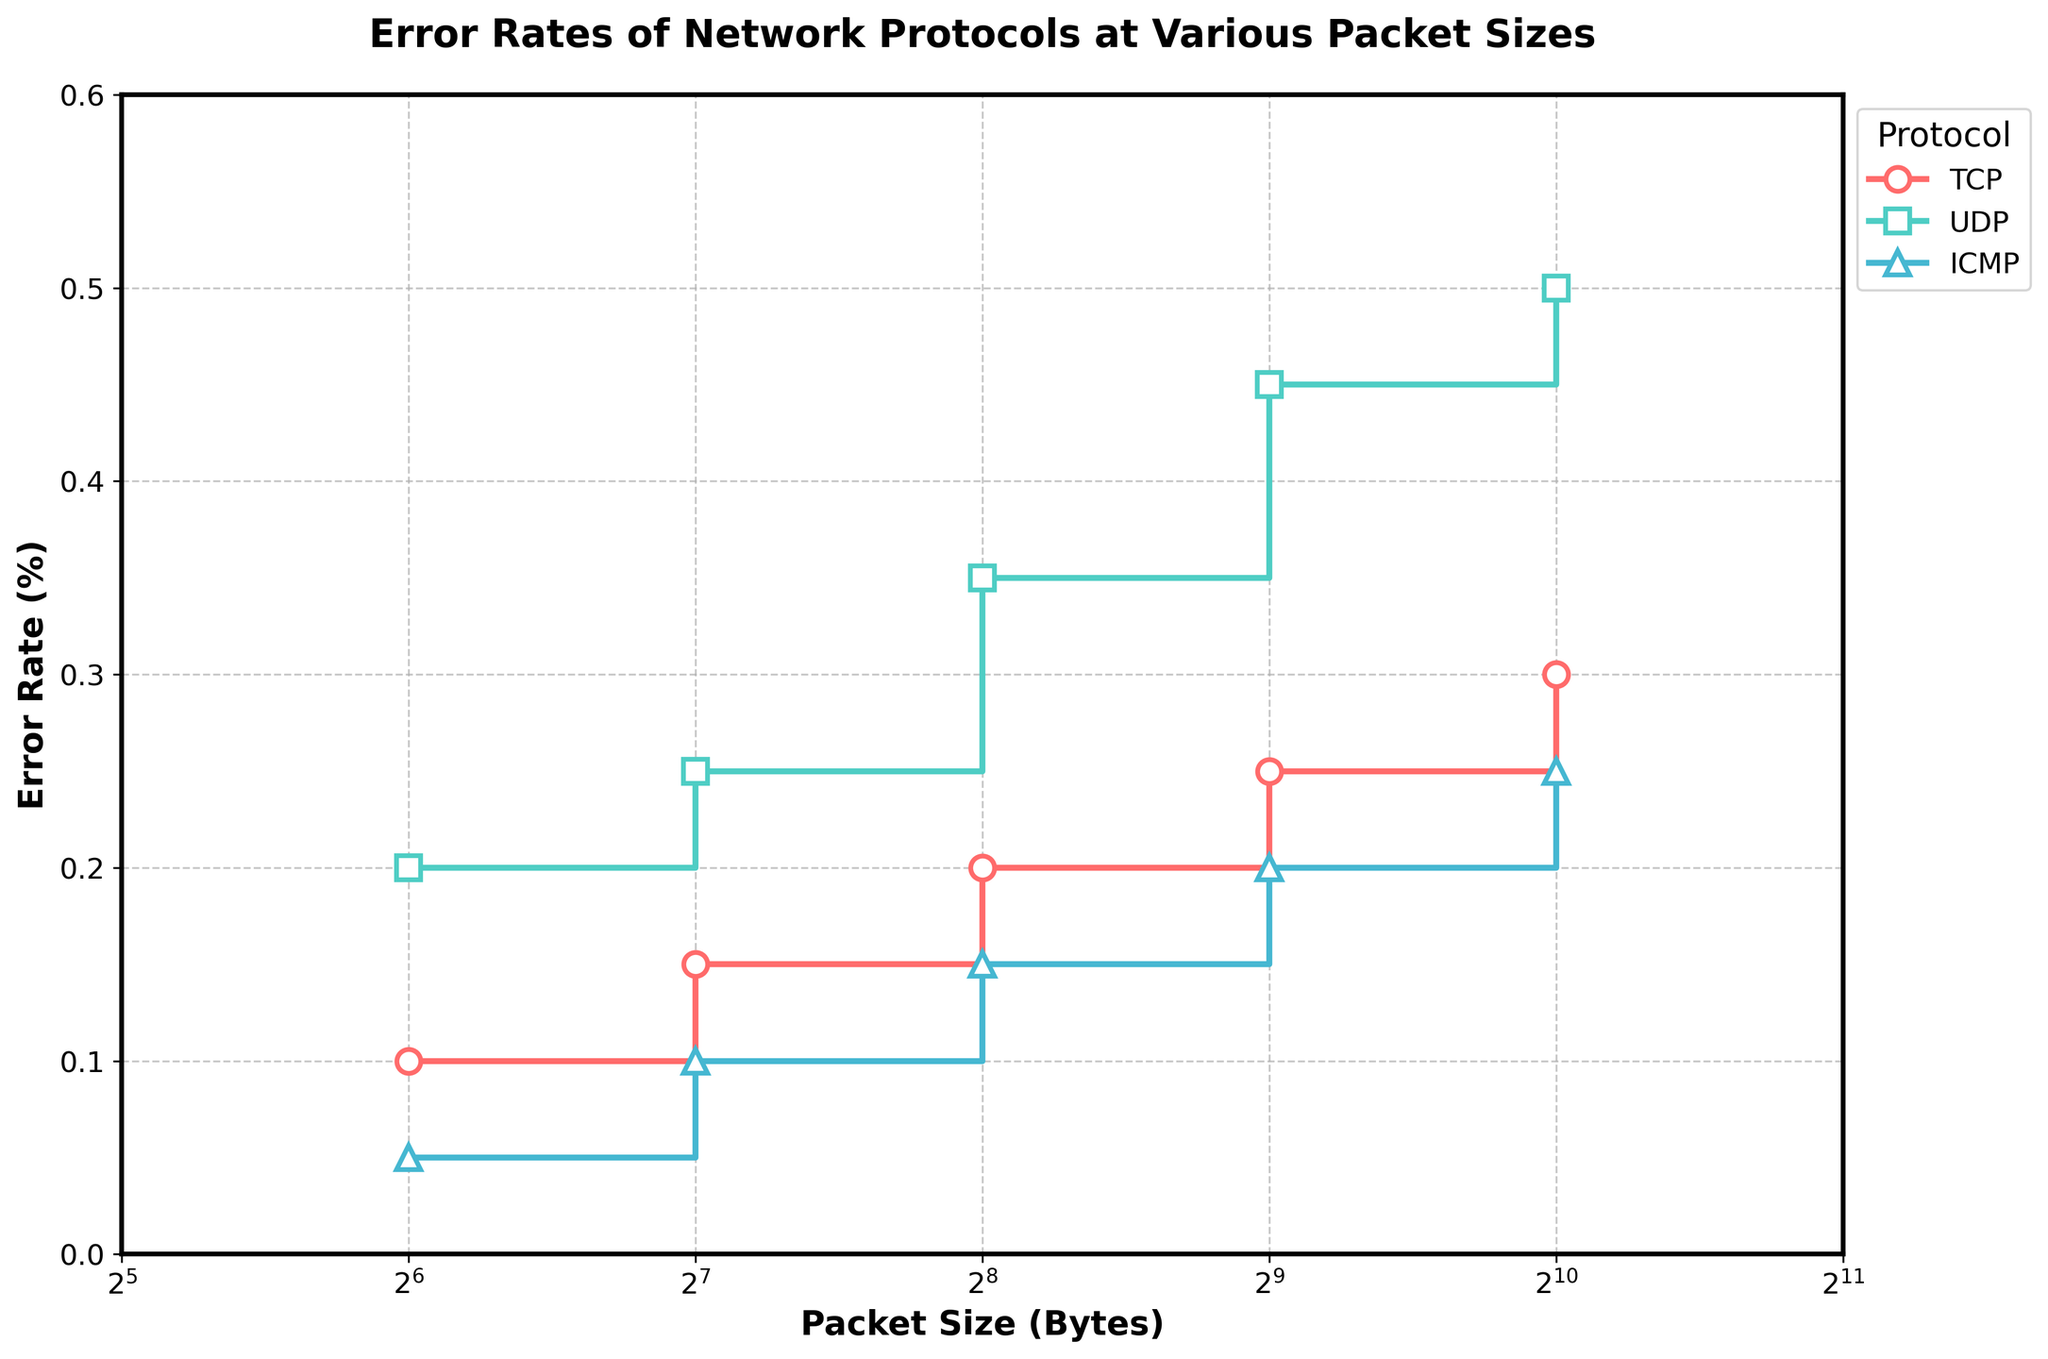What's the title of the plot? The title of the plot is usually found at the top center of the figure. It summarizes the content of the plot.
Answer: Error Rates of Network Protocols at Various Packet Sizes What are the units used for the x-axis and y-axis? The x-axis label is "Packet Size (Bytes)" indicating the units are in Bytes for packet sizes. The y-axis label is "Error Rate (%)" indicating the units are in percentage for error rates.
Answer: Bytes and percentage Which protocol shows the highest error rate at a packet size of 1024 Bytes? By looking at the end points of the stair plots, you can see the value at 1024 Bytes for each protocol. UDP shows the highest error rate at this packet size.
Answer: UDP What is the range of error rates for the TCP protocol? The range is the difference between the maximum and minimum error values for the TCP protocol. The maximum error rate for TCP is 0.3% and the minimum is 0.1%. The range is 0.3% - 0.1% = 0.2%.
Answer: 0.2% Compare the error rates of TCP and ICMP at a packet size of 256 Bytes. Which one is higher? Locate the error rates for each protocol at the 256 Bytes mark on the x-axis. TCP has an error rate of 0.2% and ICMP has 0.15%. Thus, TCP is higher.
Answer: TCP What is the average error rate for the ICMP protocol across all packet sizes? Sum the error rates for ICMP at all packet sizes and then divide by the number of data points. (0.05 + 0.1 + 0.15 + 0.2 + 0.25) / 5 = 0.75 / 5 = 0.15
Answer: 0.15% Which protocol experiences the steepest increase in error rate as packet size grows from 64 Bytes to 1024 Bytes? The steepness of an increase is determined by the slope of the stair plot. UDP shows the most significant increase from 0.2% at 64 Bytes to 0.5% at 1024 Bytes.
Answer: UDP At what packet size do all protocols present roughly equivalent error rates? Look for a packet size where the error rates intersect or are very close. At 64 Bytes, the error rates for all protocols are fairly close: TCP (0.1%), UDP (0.2%), ICMP (0.05%).
Answer: 64 Bytes 